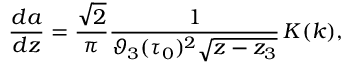Convert formula to latex. <formula><loc_0><loc_0><loc_500><loc_500>\frac { d a } { d z } = \frac { \sqrt { 2 } } { \pi } \frac { 1 } { \vartheta _ { 3 } ( \tau _ { 0 } ) ^ { 2 } \sqrt { z - z _ { 3 } } } \, K ( k ) ,</formula> 